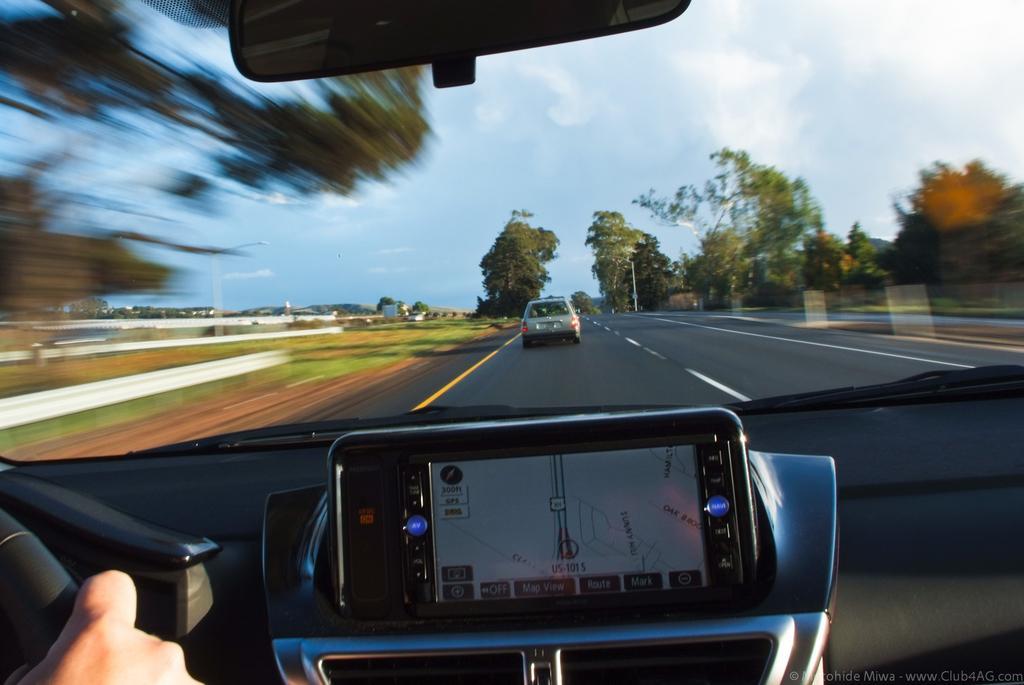How would you summarize this image in a sentence or two? In the foreground of the image we can see a screen, hand of a person, air conditioner vents. In the center of the image we can see a vehicle parked on road, a group of trees, poles and the cloudy sky. At the bottom of the image we can see some text. 